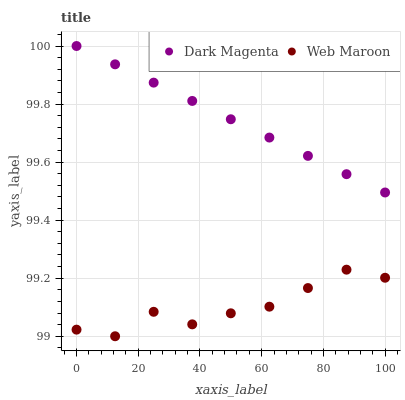Does Web Maroon have the minimum area under the curve?
Answer yes or no. Yes. Does Dark Magenta have the maximum area under the curve?
Answer yes or no. Yes. Does Dark Magenta have the minimum area under the curve?
Answer yes or no. No. Is Dark Magenta the smoothest?
Answer yes or no. Yes. Is Web Maroon the roughest?
Answer yes or no. Yes. Is Dark Magenta the roughest?
Answer yes or no. No. Does Web Maroon have the lowest value?
Answer yes or no. Yes. Does Dark Magenta have the lowest value?
Answer yes or no. No. Does Dark Magenta have the highest value?
Answer yes or no. Yes. Is Web Maroon less than Dark Magenta?
Answer yes or no. Yes. Is Dark Magenta greater than Web Maroon?
Answer yes or no. Yes. Does Web Maroon intersect Dark Magenta?
Answer yes or no. No. 